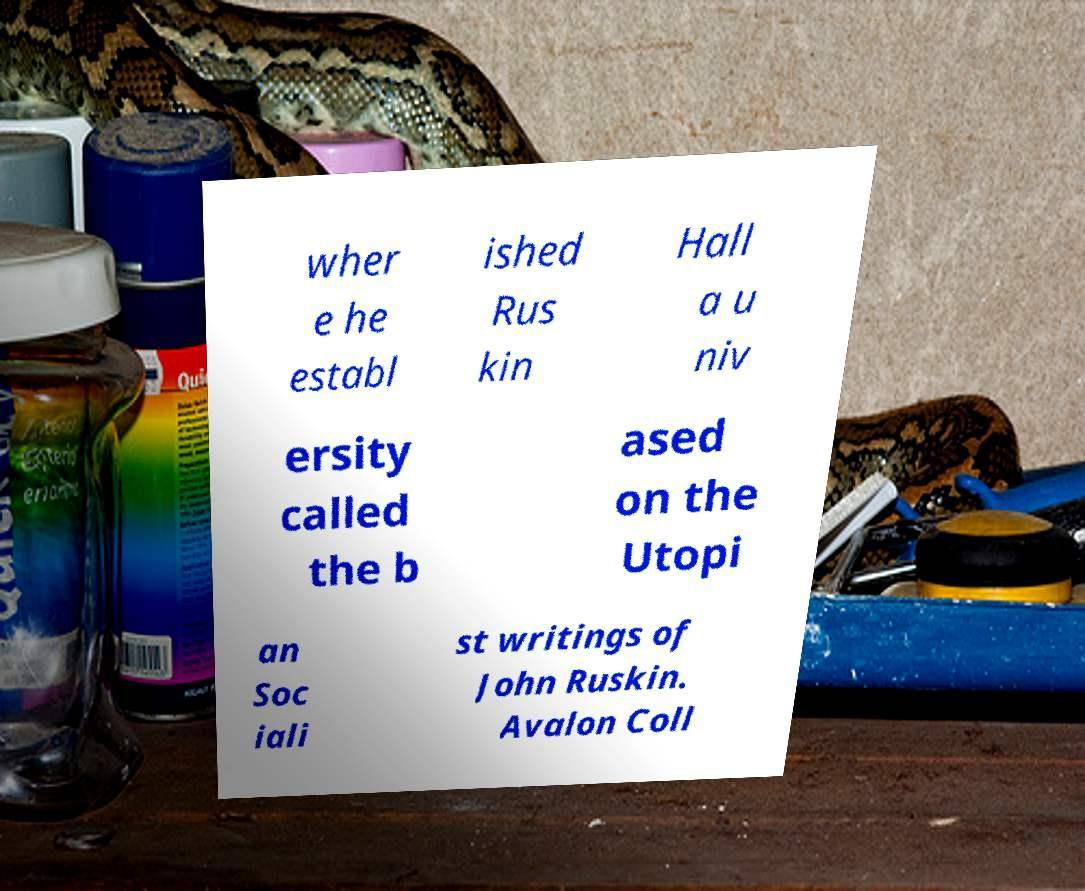What messages or text are displayed in this image? I need them in a readable, typed format. wher e he establ ished Rus kin Hall a u niv ersity called the b ased on the Utopi an Soc iali st writings of John Ruskin. Avalon Coll 